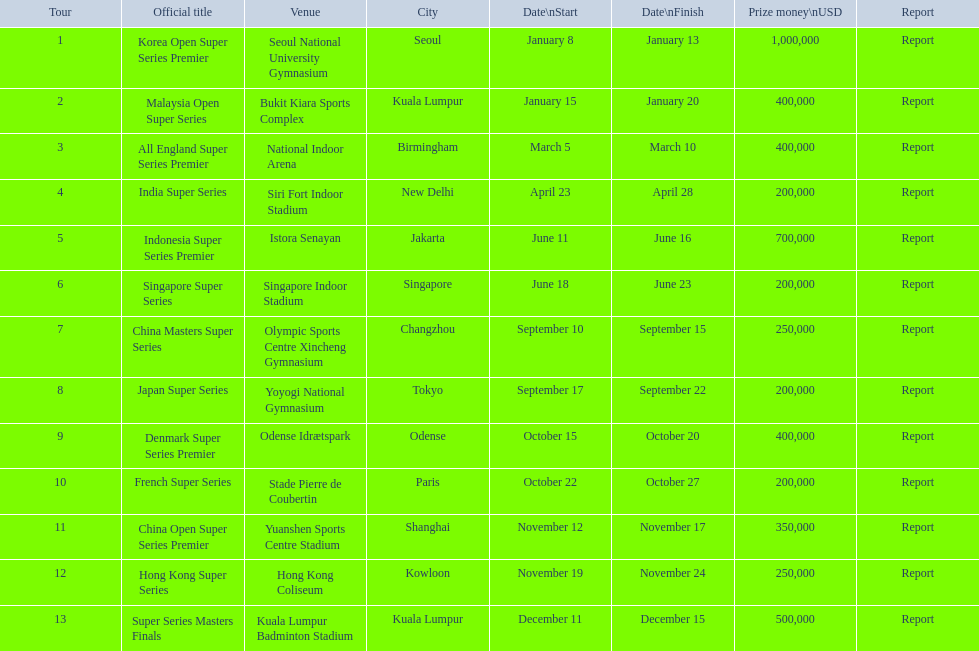Which tour was the only one to take place in december? Super Series Masters Finals. 